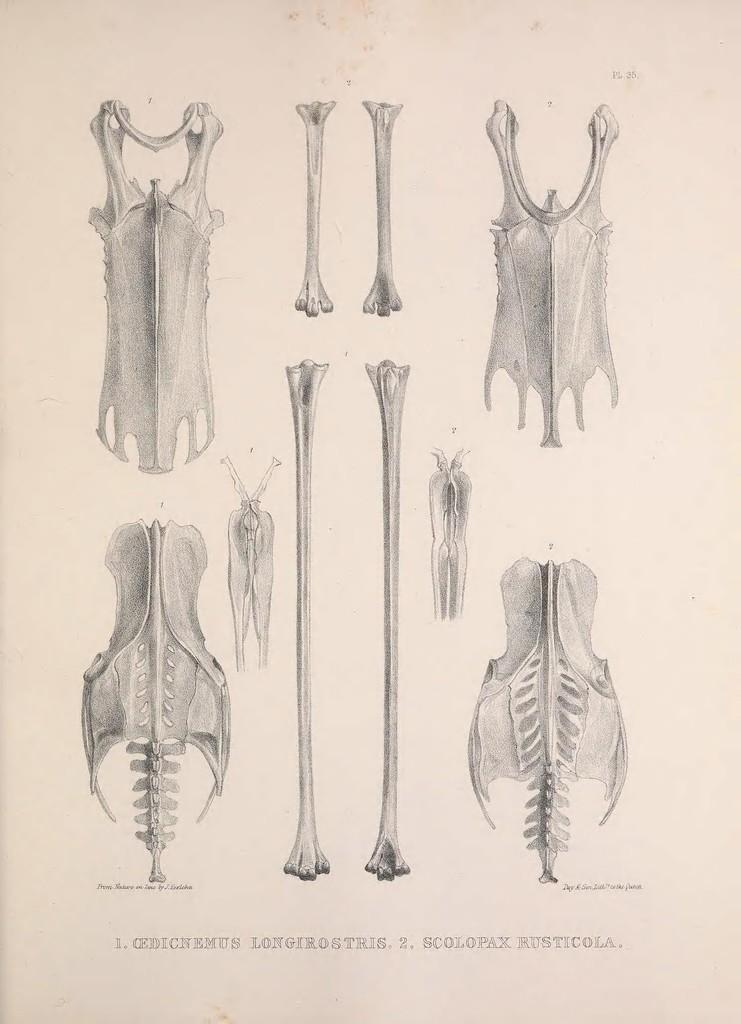What type of objects can be seen in the image? There are bones and skeletons in the image. What might the text in the image be describing or explaining? The text in the image could be providing information about the bones or skeletons. What type of bird can be seen wearing underwear in the image? There is no bird or underwear present in the image; it features bones and skeletons. 